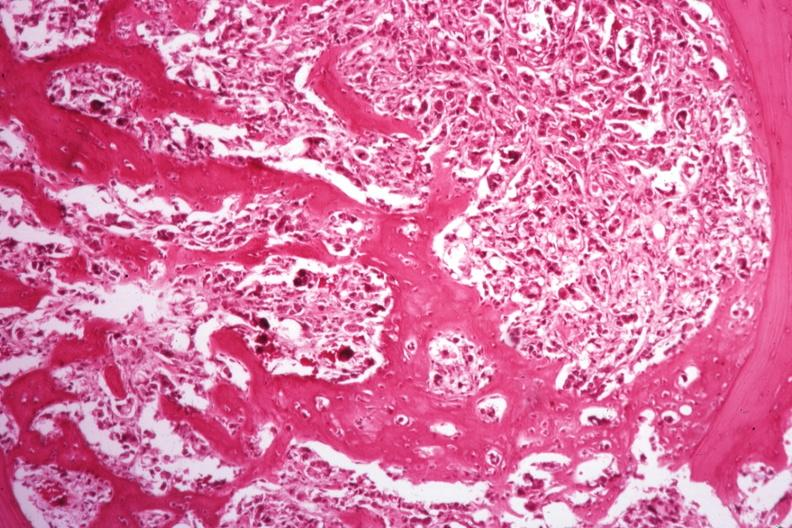s joints present?
Answer the question using a single word or phrase. Yes 